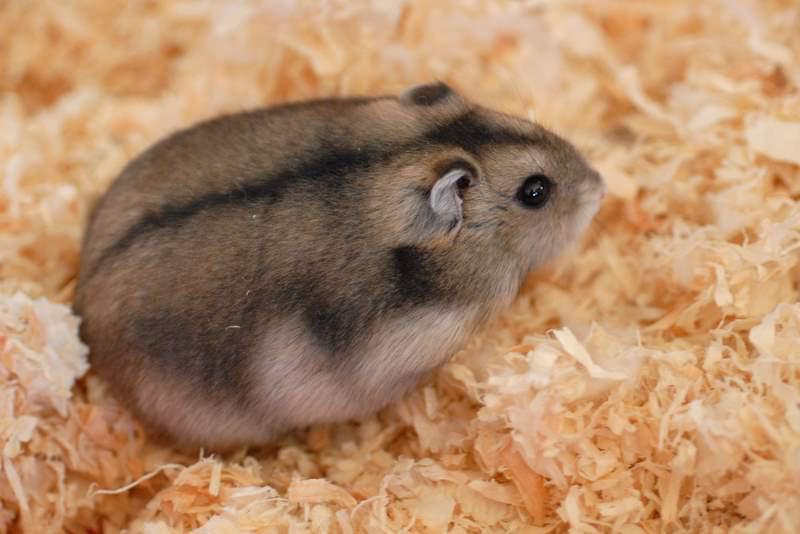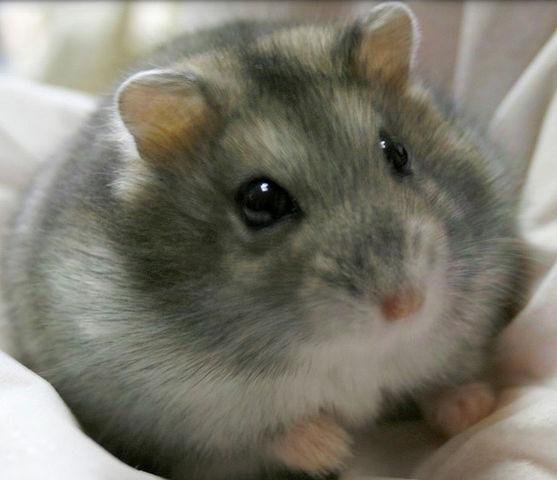The first image is the image on the left, the second image is the image on the right. Analyze the images presented: Is the assertion "Each image contains one pet rodent, with one on fabric and one on shredded bedding." valid? Answer yes or no. Yes. The first image is the image on the left, the second image is the image on the right. Evaluate the accuracy of this statement regarding the images: "In the image to the left, there is a hamster who happens to have at least half of their fur white in color.". Is it true? Answer yes or no. No. 